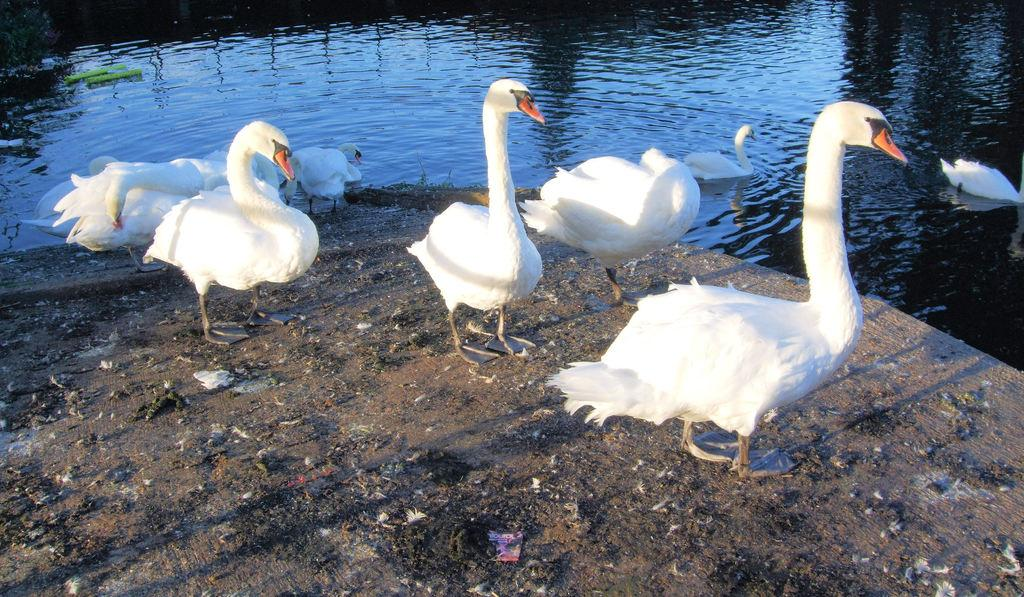What type of animals can be seen in the image? There are ducks in the image. Where are the ducks located? The ducks are in the water and on the sand. What type of screw can be seen holding the language together in the image? There is no screw or language present in the image; it features ducks in the water and on the sand. 